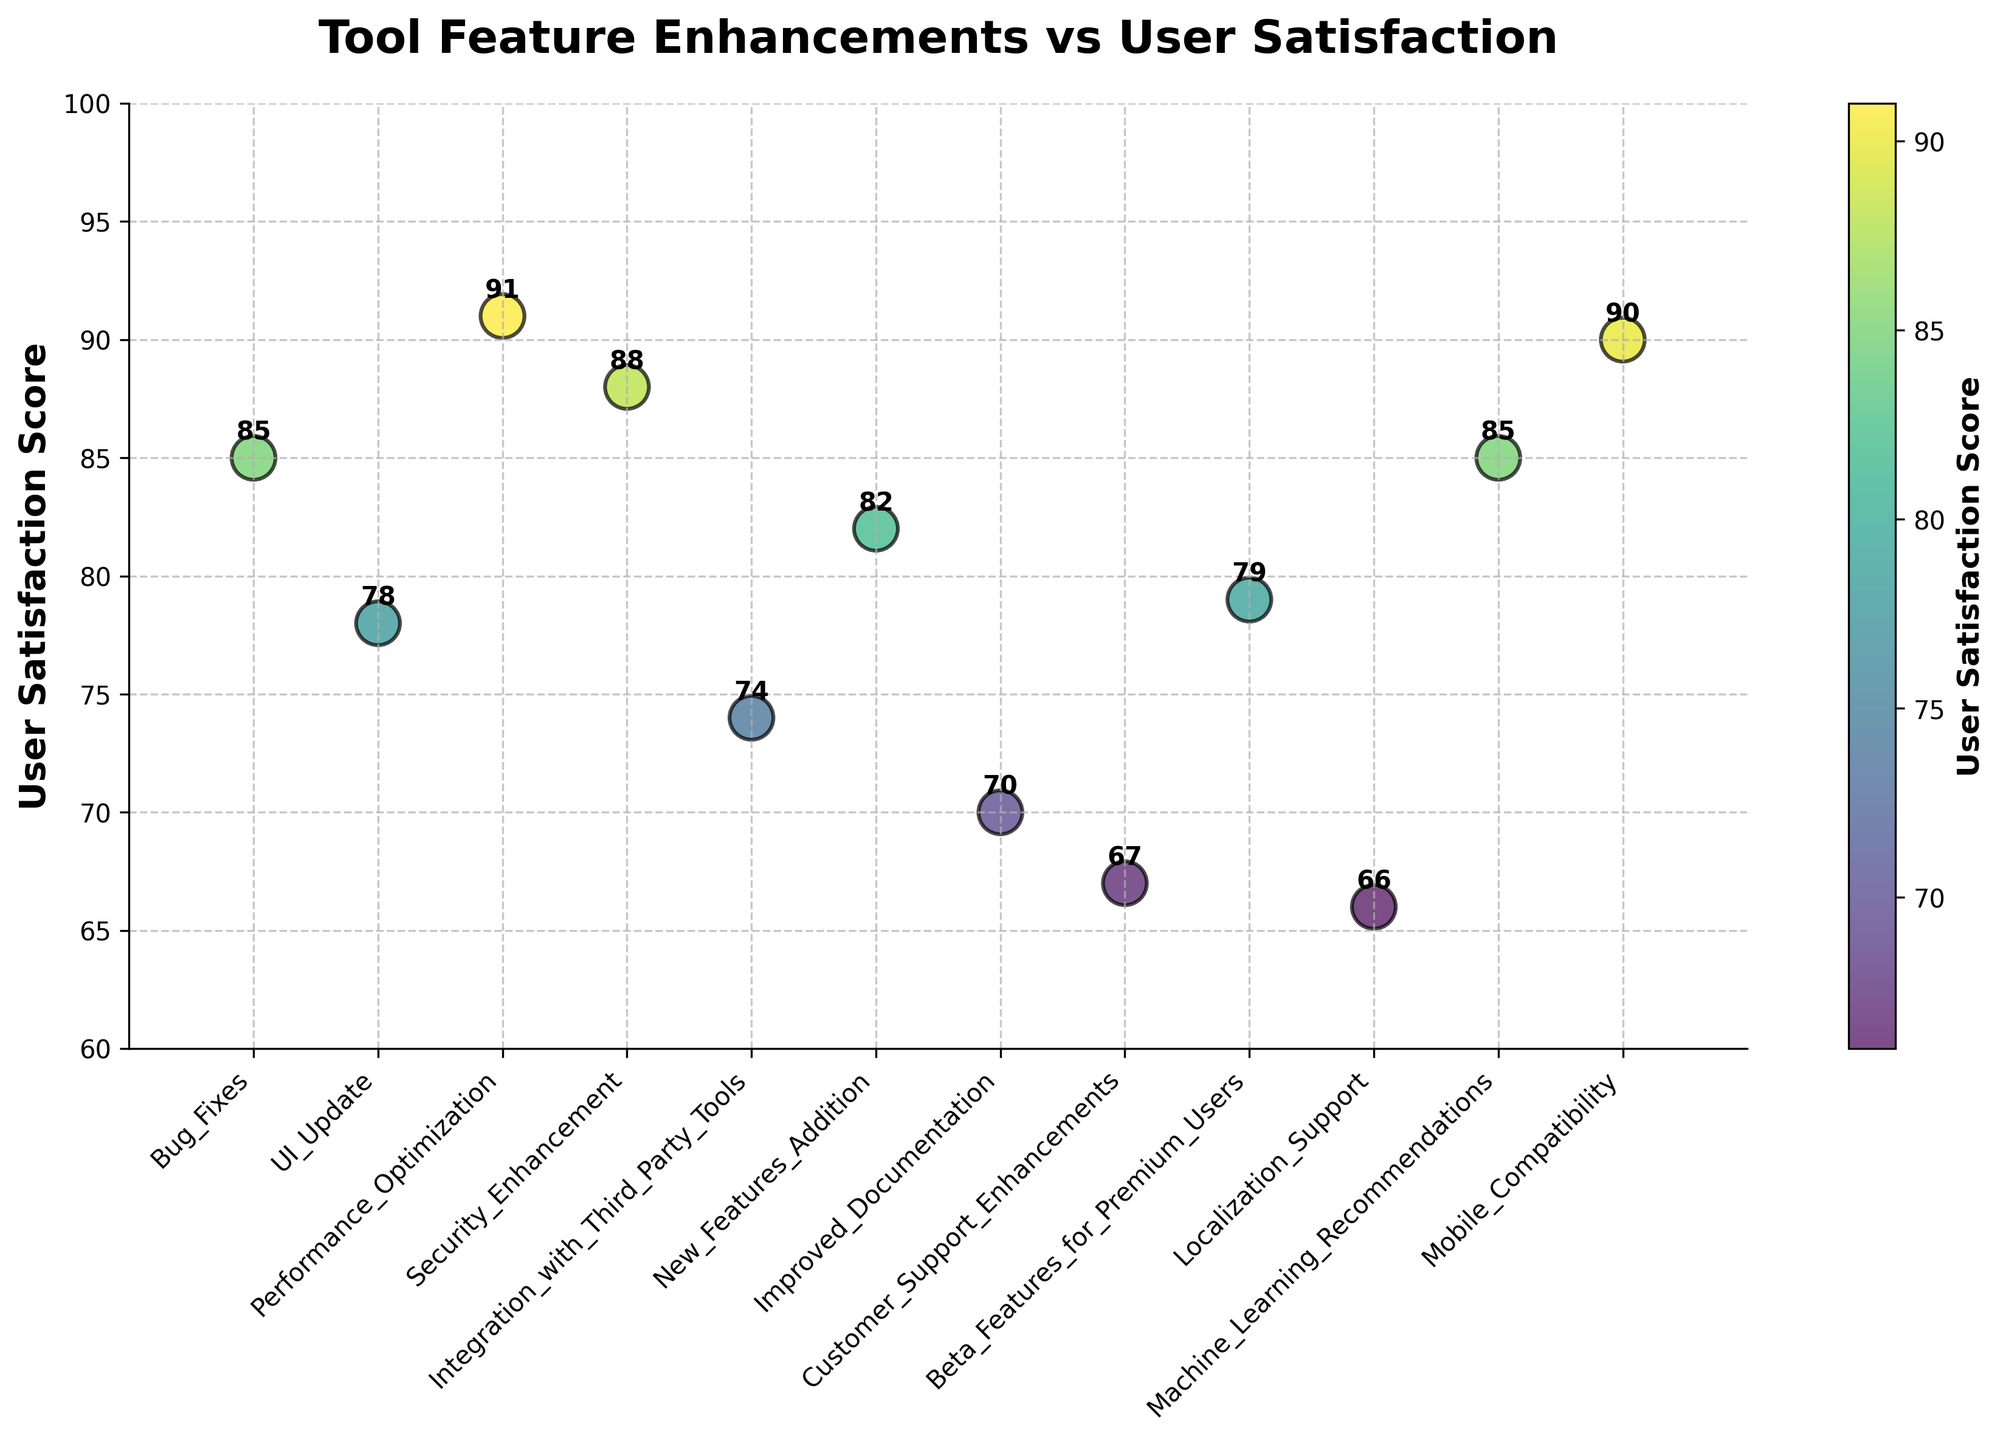Which feature enhancement has the highest user satisfaction score? By examining the y-axis values and labels of the scatter plot, the highest point corresponds to "Performance Optimization" with a score of 91.
Answer: Performance Optimization How many feature enhancements have a user satisfaction score below 80? To determine this, count the number of points below the 80 mark on the y-axis. "UI Update" (78), "Integration with Third Party Tools" (74), "Improved Documentation" (70), "Customer Support Enhancements" (67), and "Localization Support" (66) are the points below 80.
Answer: 5 What is the average user satisfaction score across all the feature enhancements? Add up all the user satisfaction scores and divide by the number of feature enhancements. The total is 85+78+91+88+74+82+70+67+79+66+85+90, summing to 945. There are 12 feature enhancements, so the average is 945/12.
Answer: 78.75 Which two feature enhancements have the closest user satisfaction scores? Look for points that are closely spaced on the y-axis. The scores for "Bug Fixes" and "Machine Learning Recommendations" are both 85, making them the closest.
Answer: Bug Fixes and Machine Learning Recommendations What is the difference in user satisfaction scores between "Mobile Compatibility" and "Localization Support"? Subtract the score of "Localization Support" (66) from "Mobile Compatibility" (90). 90 - 66 = 24.
Answer: 24 Which feature enhancement has the lowest user satisfaction score and what is the score? The point at the lowest position on the y-axis corresponds to "Localization Support" with a score of 66.
Answer: Localization Support, 66 How many feature enhancements have user satisfaction scores above 85? Count the points above the 85 mark on the y-axis. The points are "Performance Optimization" (91), "Security Enhancement" (88), and "Mobile Compatibility" (90).
Answer: 3 What is the median user satisfaction score of the feature enhancements? To find the median, first list the scores in order: 66, 67, 70, 74, 78, 79, 82, 85, 85, 88, 90, 91. With 12 data points, the median is the average of the 6th and 7th scores (79 and 82). (79+82)/2 = 80.5.
Answer: 80.5 